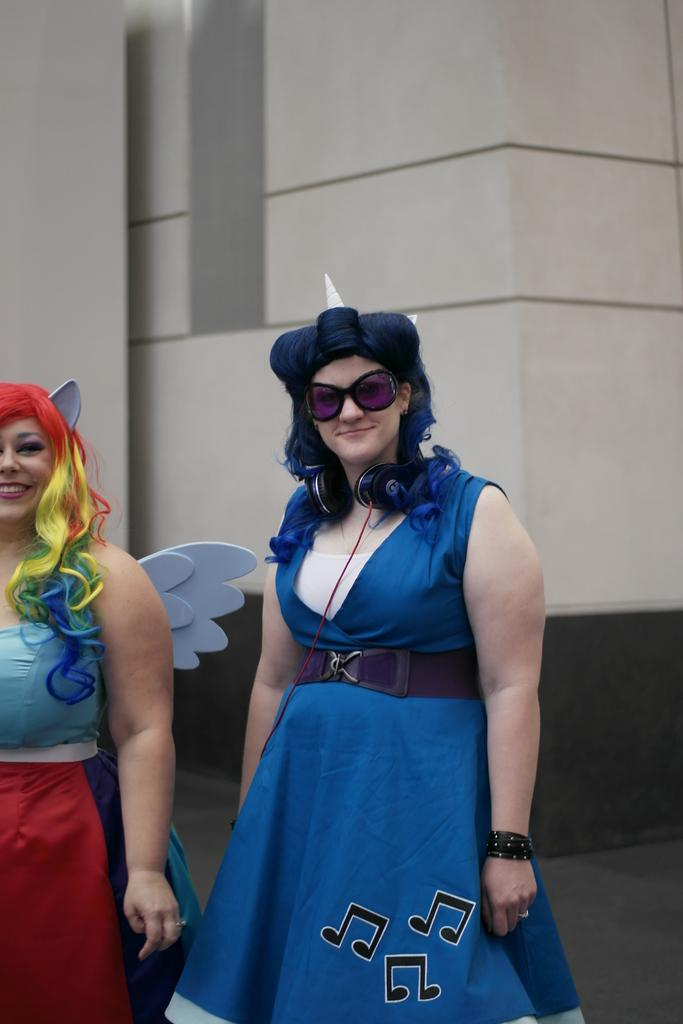How many people are in the image? There are two ladies in the image. What is the lady on the left wearing? The lady on the left is wearing goggles. What else is the lady with goggles wearing? The lady with goggles has headphones on her neck. What can be seen in the background of the image? There is a wall in the background of the image. What type of brush is the lady using to paint the wall in the image? There is no brush or painting activity present in the image. 